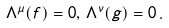Convert formula to latex. <formula><loc_0><loc_0><loc_500><loc_500>\Lambda ^ { \mu } ( f ) = 0 , \, \Lambda ^ { \nu } ( g ) = 0 \, .</formula> 